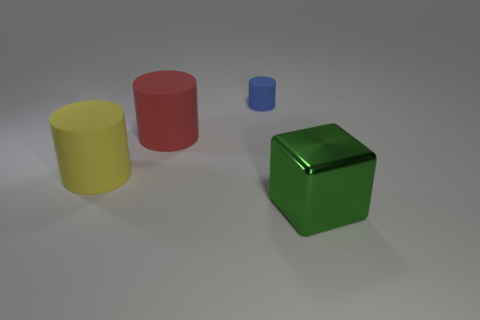What number of other objects are the same color as the large block?
Make the answer very short. 0. Is the size of the object that is in front of the yellow matte cylinder the same as the object behind the big red cylinder?
Provide a succinct answer. No. Are there an equal number of tiny cylinders on the right side of the small cylinder and big yellow things on the right side of the red matte cylinder?
Your answer should be very brief. Yes. Is there anything else that has the same material as the large red cylinder?
Keep it short and to the point. Yes. There is a green metallic block; is it the same size as the rubber object that is in front of the red matte object?
Your answer should be compact. Yes. What material is the big object to the right of the thing that is behind the large red matte cylinder?
Make the answer very short. Metal. Are there an equal number of large metallic blocks that are on the right side of the big yellow thing and big blocks?
Give a very brief answer. Yes. There is a thing that is both behind the big green metal object and in front of the red thing; what is its size?
Provide a succinct answer. Large. What is the color of the big cylinder behind the big cylinder that is in front of the red cylinder?
Offer a very short reply. Red. How many green things are small matte cylinders or metal things?
Make the answer very short. 1. 